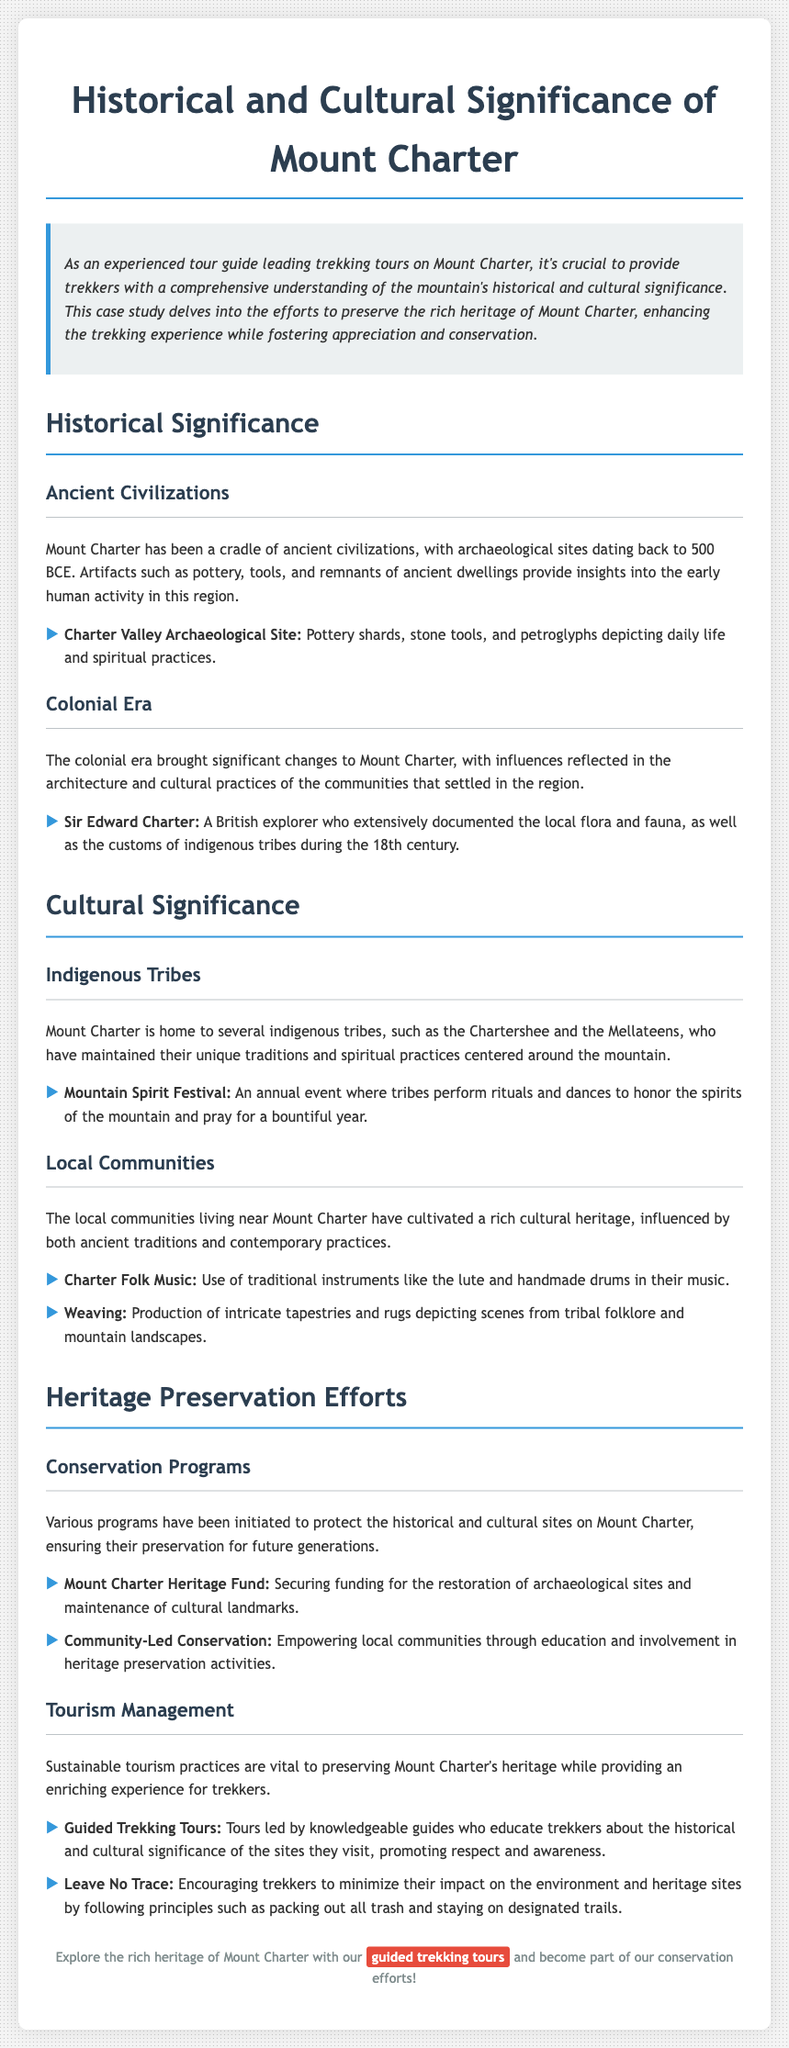What year do the archaeological sites date back to? The document states that archaeological sites on Mount Charter date back to 500 BCE.
Answer: 500 BCE Who was a British explorer that documented the local flora and fauna? The case study mentions Sir Edward Charter as the British explorer who documented the local flora and fauna, as well as customs.
Answer: Sir Edward Charter What is the annual event honoring the spirits of the mountain called? The document describes the Mountain Spirit Festival as the annual event performed by indigenous tribes to honor mountain spirits.
Answer: Mountain Spirit Festival What type of funding is provided by the Mount Charter Heritage Fund? The Mount Charter Heritage Fund secures funding for the restoration of archaeological sites and maintenance of cultural landmarks.
Answer: Restoration and maintenance funding What is encouraged under sustainable tourism practices for trekkers? The document states that trekkers are encouraged to follow Leave No Trace principles to minimize their impact on the environment and heritage sites.
Answer: Leave No Trace 